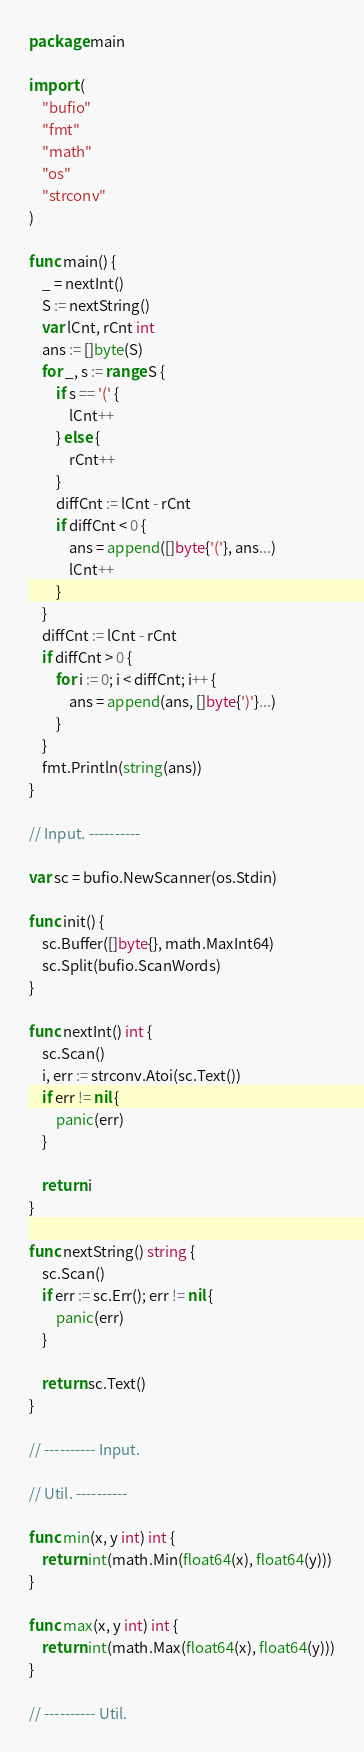Convert code to text. <code><loc_0><loc_0><loc_500><loc_500><_Go_>package main

import (
	"bufio"
	"fmt"
	"math"
	"os"
	"strconv"
)

func main() {
	_ = nextInt()
	S := nextString()
	var lCnt, rCnt int
	ans := []byte(S)
	for _, s := range S {
		if s == '(' {
			lCnt++
		} else {
			rCnt++
		}
		diffCnt := lCnt - rCnt
		if diffCnt < 0 {
			ans = append([]byte{'('}, ans...)
			lCnt++
		}
	}
	diffCnt := lCnt - rCnt
	if diffCnt > 0 {
		for i := 0; i < diffCnt; i++ {
			ans = append(ans, []byte{')'}...)
		}
	}
	fmt.Println(string(ans))
}

// Input. ----------

var sc = bufio.NewScanner(os.Stdin)

func init() {
	sc.Buffer([]byte{}, math.MaxInt64)
	sc.Split(bufio.ScanWords)
}

func nextInt() int {
	sc.Scan()
	i, err := strconv.Atoi(sc.Text())
	if err != nil {
		panic(err)
	}

	return i
}

func nextString() string {
	sc.Scan()
	if err := sc.Err(); err != nil {
		panic(err)
	}

	return sc.Text()
}

// ---------- Input.

// Util. ----------

func min(x, y int) int {
	return int(math.Min(float64(x), float64(y)))
}

func max(x, y int) int {
	return int(math.Max(float64(x), float64(y)))
}

// ---------- Util.
</code> 